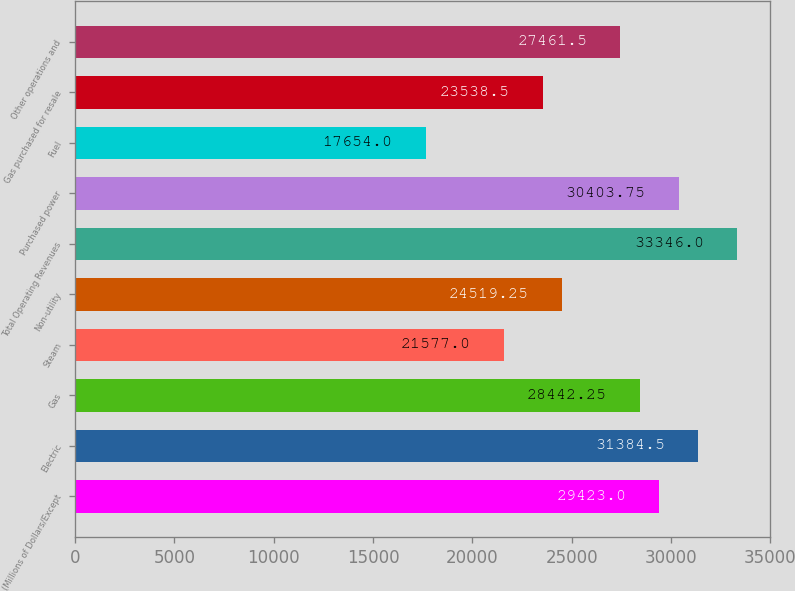Convert chart to OTSL. <chart><loc_0><loc_0><loc_500><loc_500><bar_chart><fcel>(Millions of Dollars/Except<fcel>Electric<fcel>Gas<fcel>Steam<fcel>Non-utility<fcel>Total Operating Revenues<fcel>Purchased power<fcel>Fuel<fcel>Gas purchased for resale<fcel>Other operations and<nl><fcel>29423<fcel>31384.5<fcel>28442.2<fcel>21577<fcel>24519.2<fcel>33346<fcel>30403.8<fcel>17654<fcel>23538.5<fcel>27461.5<nl></chart> 